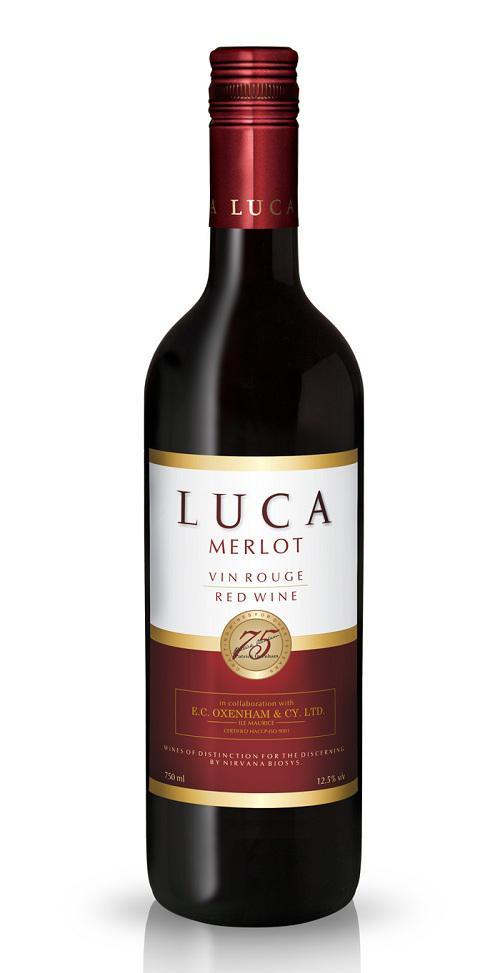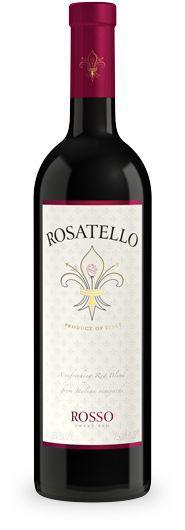The first image is the image on the left, the second image is the image on the right. Given the left and right images, does the statement "The bottle in the image on the left has a screw-off cap." hold true? Answer yes or no. Yes. 